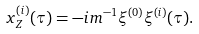<formula> <loc_0><loc_0><loc_500><loc_500>x ^ { ( i ) } _ { Z } ( \tau ) = - i m ^ { - 1 } \xi ^ { ( 0 ) } \xi ^ { ( i ) } ( \tau ) .</formula> 